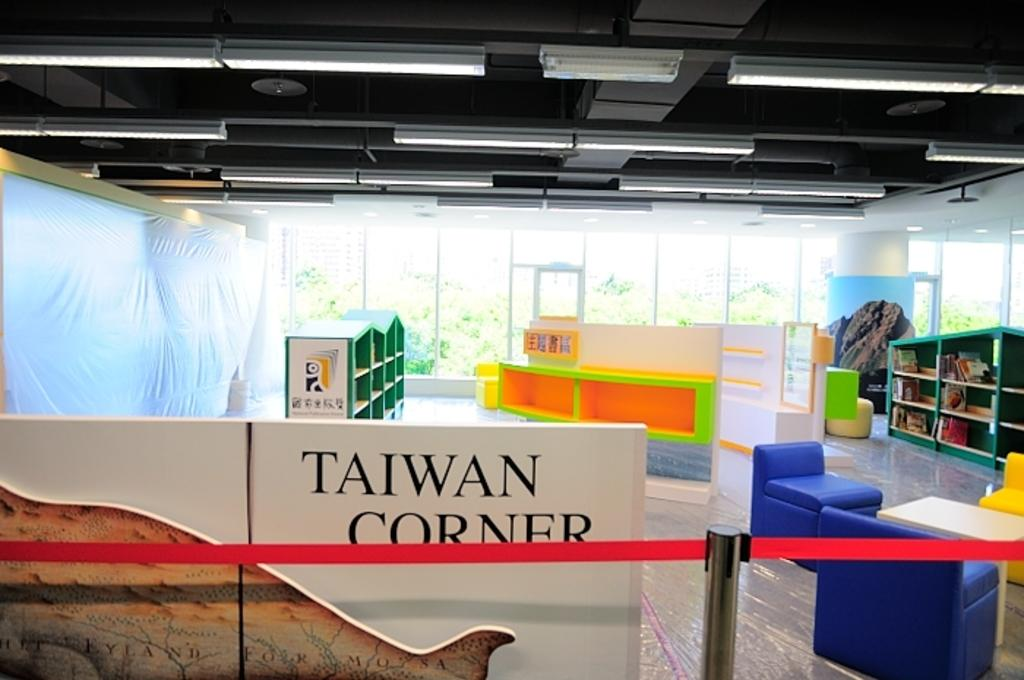<image>
Present a compact description of the photo's key features. A childrens room named Taiwan Corner next to a map. 